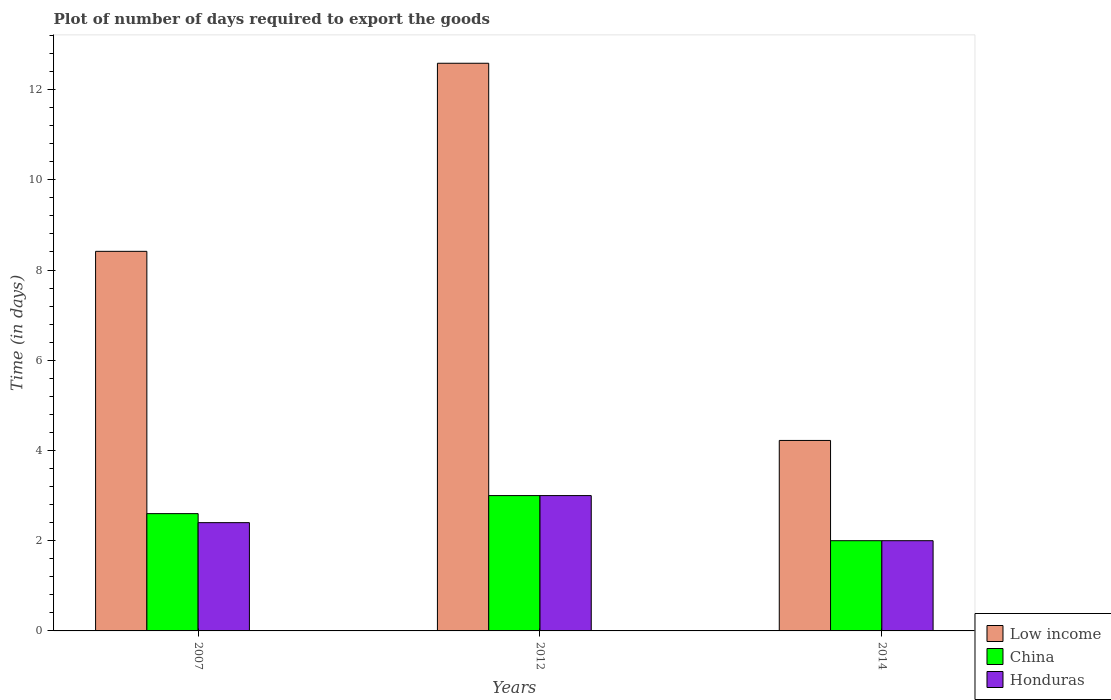Are the number of bars per tick equal to the number of legend labels?
Ensure brevity in your answer.  Yes. Are the number of bars on each tick of the X-axis equal?
Your answer should be very brief. Yes. How many bars are there on the 1st tick from the left?
Give a very brief answer. 3. What is the label of the 3rd group of bars from the left?
Offer a terse response. 2014. In how many cases, is the number of bars for a given year not equal to the number of legend labels?
Provide a succinct answer. 0. What is the time required to export goods in Honduras in 2014?
Ensure brevity in your answer.  2. Across all years, what is the maximum time required to export goods in China?
Give a very brief answer. 3. In which year was the time required to export goods in Low income minimum?
Your answer should be compact. 2014. What is the total time required to export goods in China in the graph?
Provide a short and direct response. 7.6. What is the difference between the time required to export goods in Honduras in 2007 and that in 2012?
Your answer should be compact. -0.6. What is the difference between the time required to export goods in Low income in 2014 and the time required to export goods in China in 2012?
Your answer should be compact. 1.22. What is the average time required to export goods in Honduras per year?
Make the answer very short. 2.47. In the year 2014, what is the difference between the time required to export goods in Low income and time required to export goods in China?
Provide a succinct answer. 2.22. Is the difference between the time required to export goods in Low income in 2012 and 2014 greater than the difference between the time required to export goods in China in 2012 and 2014?
Provide a succinct answer. Yes. What is the difference between the highest and the second highest time required to export goods in Honduras?
Keep it short and to the point. 0.6. In how many years, is the time required to export goods in China greater than the average time required to export goods in China taken over all years?
Offer a very short reply. 2. What does the 1st bar from the right in 2012 represents?
Offer a very short reply. Honduras. Are all the bars in the graph horizontal?
Offer a terse response. No. How many years are there in the graph?
Keep it short and to the point. 3. What is the difference between two consecutive major ticks on the Y-axis?
Keep it short and to the point. 2. Are the values on the major ticks of Y-axis written in scientific E-notation?
Your answer should be very brief. No. Does the graph contain any zero values?
Provide a succinct answer. No. What is the title of the graph?
Offer a terse response. Plot of number of days required to export the goods. What is the label or title of the X-axis?
Your answer should be very brief. Years. What is the label or title of the Y-axis?
Offer a very short reply. Time (in days). What is the Time (in days) of Low income in 2007?
Keep it short and to the point. 8.41. What is the Time (in days) of Honduras in 2007?
Your answer should be very brief. 2.4. What is the Time (in days) of Low income in 2012?
Ensure brevity in your answer.  12.58. What is the Time (in days) of Low income in 2014?
Give a very brief answer. 4.22. What is the Time (in days) in Honduras in 2014?
Provide a succinct answer. 2. Across all years, what is the maximum Time (in days) in Low income?
Ensure brevity in your answer.  12.58. Across all years, what is the maximum Time (in days) of China?
Make the answer very short. 3. Across all years, what is the minimum Time (in days) in Low income?
Keep it short and to the point. 4.22. Across all years, what is the minimum Time (in days) in China?
Your response must be concise. 2. What is the total Time (in days) of Low income in the graph?
Ensure brevity in your answer.  25.22. What is the difference between the Time (in days) of Low income in 2007 and that in 2012?
Offer a terse response. -4.17. What is the difference between the Time (in days) of China in 2007 and that in 2012?
Give a very brief answer. -0.4. What is the difference between the Time (in days) of Honduras in 2007 and that in 2012?
Ensure brevity in your answer.  -0.6. What is the difference between the Time (in days) of Low income in 2007 and that in 2014?
Offer a very short reply. 4.19. What is the difference between the Time (in days) of China in 2007 and that in 2014?
Offer a very short reply. 0.6. What is the difference between the Time (in days) of Honduras in 2007 and that in 2014?
Make the answer very short. 0.4. What is the difference between the Time (in days) of Low income in 2012 and that in 2014?
Keep it short and to the point. 8.36. What is the difference between the Time (in days) of Low income in 2007 and the Time (in days) of China in 2012?
Provide a succinct answer. 5.41. What is the difference between the Time (in days) in Low income in 2007 and the Time (in days) in Honduras in 2012?
Offer a very short reply. 5.41. What is the difference between the Time (in days) of Low income in 2007 and the Time (in days) of China in 2014?
Provide a short and direct response. 6.41. What is the difference between the Time (in days) of Low income in 2007 and the Time (in days) of Honduras in 2014?
Ensure brevity in your answer.  6.41. What is the difference between the Time (in days) in Low income in 2012 and the Time (in days) in China in 2014?
Ensure brevity in your answer.  10.58. What is the difference between the Time (in days) in Low income in 2012 and the Time (in days) in Honduras in 2014?
Offer a terse response. 10.58. What is the average Time (in days) in Low income per year?
Ensure brevity in your answer.  8.41. What is the average Time (in days) in China per year?
Your response must be concise. 2.53. What is the average Time (in days) in Honduras per year?
Offer a very short reply. 2.47. In the year 2007, what is the difference between the Time (in days) in Low income and Time (in days) in China?
Give a very brief answer. 5.81. In the year 2007, what is the difference between the Time (in days) of Low income and Time (in days) of Honduras?
Your answer should be very brief. 6.01. In the year 2012, what is the difference between the Time (in days) in Low income and Time (in days) in China?
Your response must be concise. 9.58. In the year 2012, what is the difference between the Time (in days) in Low income and Time (in days) in Honduras?
Provide a short and direct response. 9.58. In the year 2012, what is the difference between the Time (in days) of China and Time (in days) of Honduras?
Give a very brief answer. 0. In the year 2014, what is the difference between the Time (in days) of Low income and Time (in days) of China?
Ensure brevity in your answer.  2.22. In the year 2014, what is the difference between the Time (in days) of Low income and Time (in days) of Honduras?
Make the answer very short. 2.22. What is the ratio of the Time (in days) in Low income in 2007 to that in 2012?
Give a very brief answer. 0.67. What is the ratio of the Time (in days) in China in 2007 to that in 2012?
Your answer should be very brief. 0.87. What is the ratio of the Time (in days) in Honduras in 2007 to that in 2012?
Offer a terse response. 0.8. What is the ratio of the Time (in days) in Low income in 2007 to that in 2014?
Your response must be concise. 1.99. What is the ratio of the Time (in days) of China in 2007 to that in 2014?
Offer a terse response. 1.3. What is the ratio of the Time (in days) of Honduras in 2007 to that in 2014?
Offer a terse response. 1.2. What is the ratio of the Time (in days) of Low income in 2012 to that in 2014?
Your response must be concise. 2.98. What is the ratio of the Time (in days) of Honduras in 2012 to that in 2014?
Make the answer very short. 1.5. What is the difference between the highest and the second highest Time (in days) of Low income?
Provide a short and direct response. 4.17. What is the difference between the highest and the second highest Time (in days) in Honduras?
Make the answer very short. 0.6. What is the difference between the highest and the lowest Time (in days) of Low income?
Keep it short and to the point. 8.36. 